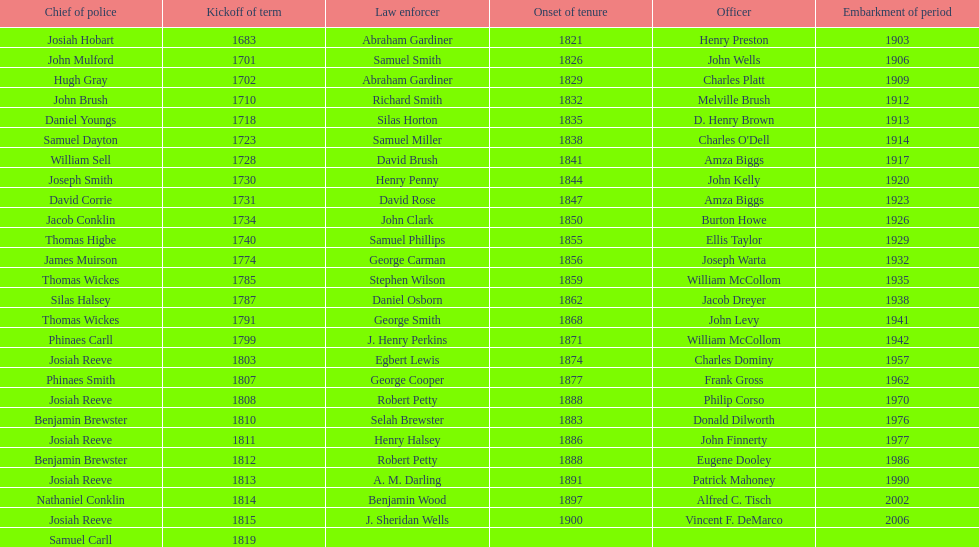Which sheriff came before thomas wickes? James Muirson. 